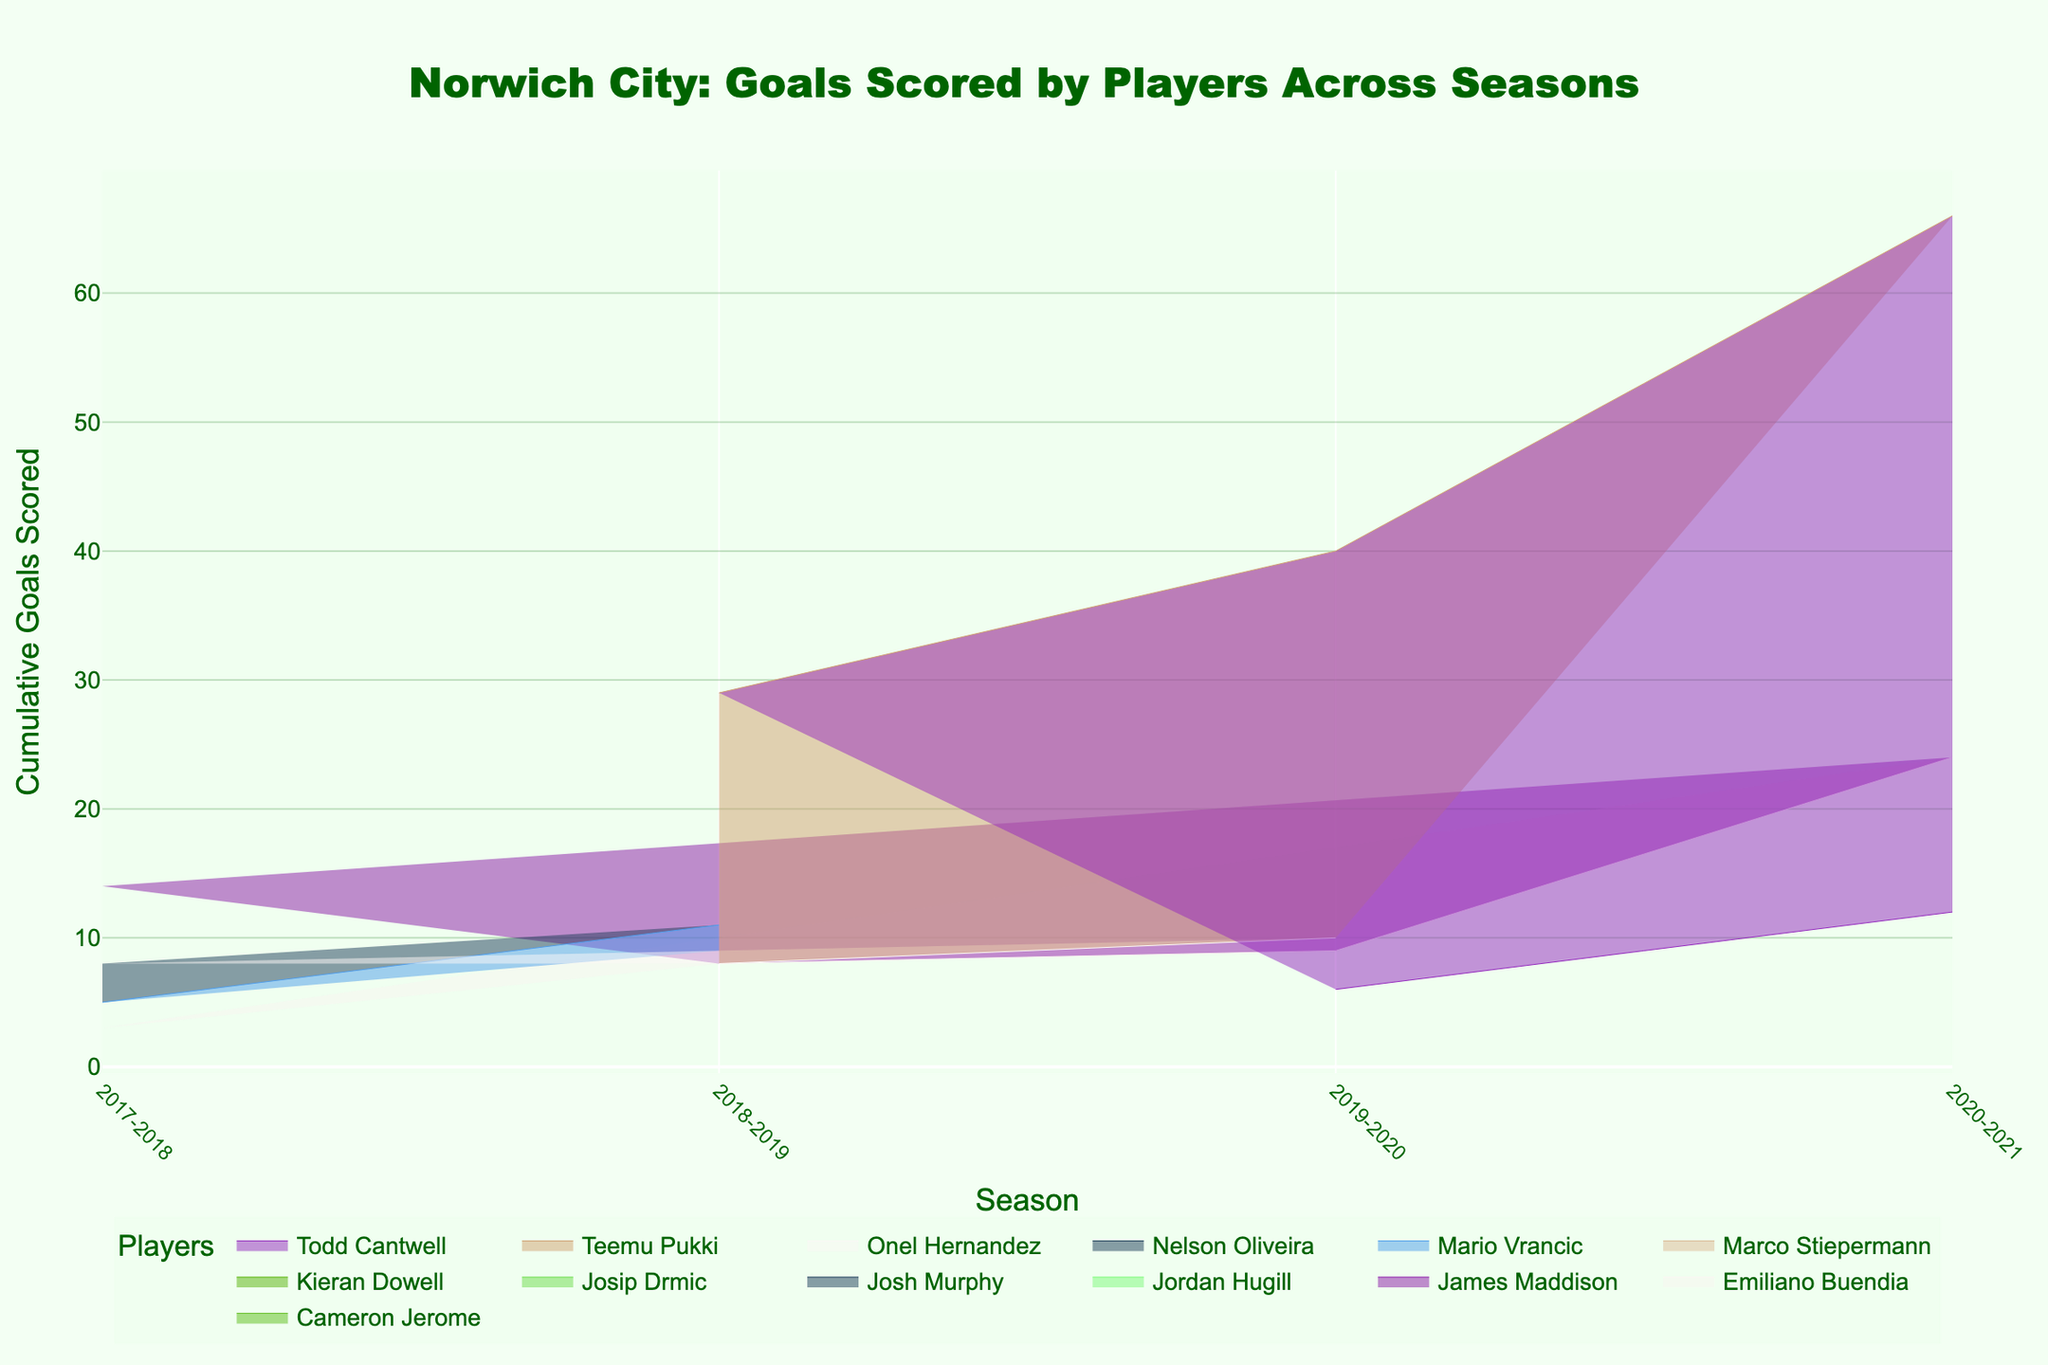what is the title of the chart? The title of a chart is typically displayed at the top of the chart and provides a summary of what the chart is about. In this area chart, the title is clearly shown.
Answer: Norwich City: Goals Scored by Players Across Seasons How many seasons are covered in the chart? The x-axis of the chart, representing the seasons, provides the information. By counting the number of distinct labels on the x-axis, we can determine the number of seasons.
Answer: 4 Which player scored the most goals in a single season? Looking at the area segments for different players in each season, we identify the most prominent segment within a particular season. Teemu Pukki's segment in the 2018-2019 season stands out.
Answer: Teemu Pukki (2018-2019) What was the total number of goals scored by Teemu Pukki across all seasons? For this, we look at the cumulative height representing Teemu Pukki across all seasons and sum these values from each season: 29 (2018-2019) + 11 (2019-2020) + 26 (2020-2021).
Answer: 66 Who scored more goals, Teemu Pukki in the 2020-2021 season or the entire team in the 2017-2018 season? First, identify Teemu Pukki's goals in the 2020-2021 season (26). Then sum goals from all players for the 2017-2018 season: 14+8+5+3+7 = 37. Compare the two values.
Answer: The entire team in the 2017-2018 season Which player had a consistent presence across multiple seasons? Track the segments representing each player across different seasons. Players like Emiliano Buendia, who appear in multiple seasons, show consistency.
Answer: Emiliano Buendia How did the team’s overall goal-scoring trend change from 2017-2018 to 2020-2021? Observe the cumulative goal heights and the relative size of segments across the seasons. The size of the segments increases considerably in the 2018-2019 and 2020-2021 seasons, indicating a higher total goal count.
Answer: The overall goal-scoring increased significantly What season had the lowest number of goals scored by players? Identify the season with the smallest cumulative height of the area. The segments in the 2017-2018 season collectively demonstrate lower heights than other seasons.
Answer: 2017-2018 How many different players contributed to the goal tally in the 2020-2021 season? Each differently colored area segment represents a distinct player. By counting these segments for the 2020-2021 season, we determine the number of players.
Answer: 5 